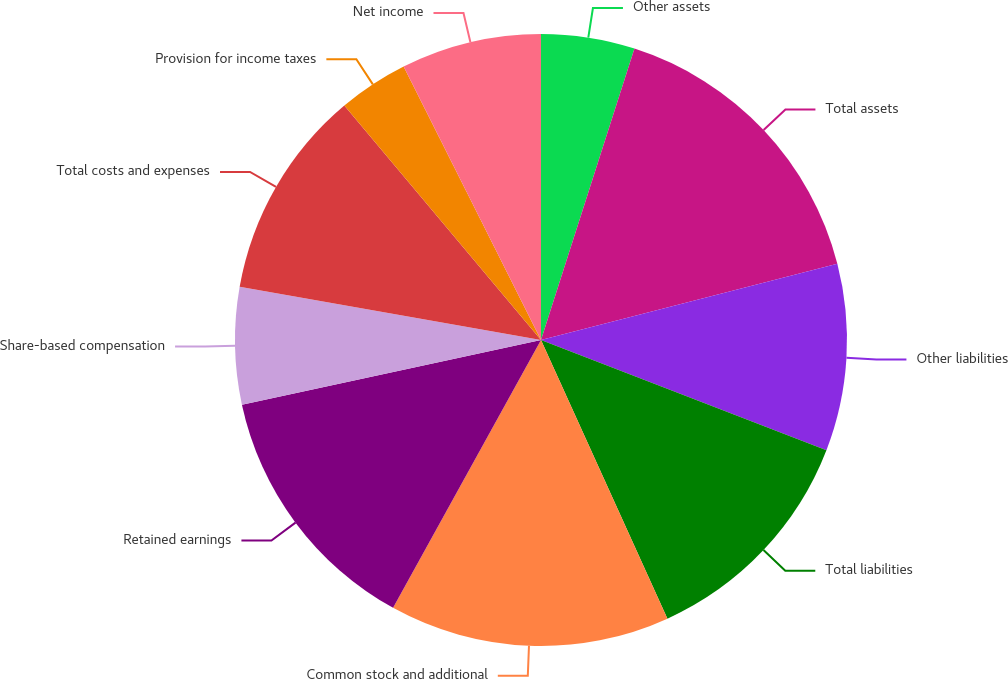Convert chart to OTSL. <chart><loc_0><loc_0><loc_500><loc_500><pie_chart><fcel>Other assets<fcel>Total assets<fcel>Other liabilities<fcel>Total liabilities<fcel>Common stock and additional<fcel>Retained earnings<fcel>Share-based compensation<fcel>Total costs and expenses<fcel>Provision for income taxes<fcel>Net income<nl><fcel>4.94%<fcel>16.05%<fcel>9.88%<fcel>12.35%<fcel>14.81%<fcel>13.58%<fcel>6.17%<fcel>11.11%<fcel>3.7%<fcel>7.41%<nl></chart> 